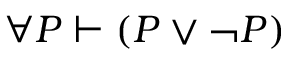Convert formula to latex. <formula><loc_0><loc_0><loc_500><loc_500>\forall P \vdash ( P \lor \ln o t P )</formula> 